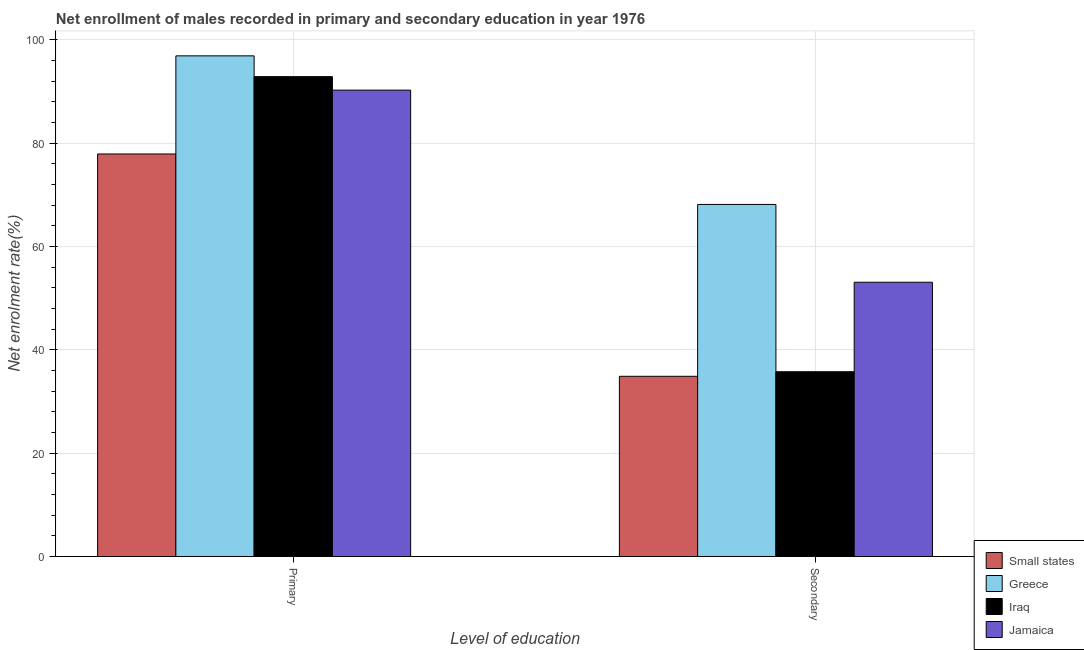How many different coloured bars are there?
Give a very brief answer. 4. Are the number of bars on each tick of the X-axis equal?
Ensure brevity in your answer.  Yes. How many bars are there on the 2nd tick from the left?
Your response must be concise. 4. What is the label of the 2nd group of bars from the left?
Offer a terse response. Secondary. What is the enrollment rate in secondary education in Iraq?
Make the answer very short. 35.76. Across all countries, what is the maximum enrollment rate in primary education?
Your answer should be very brief. 96.88. Across all countries, what is the minimum enrollment rate in primary education?
Ensure brevity in your answer.  77.89. In which country was the enrollment rate in primary education minimum?
Give a very brief answer. Small states. What is the total enrollment rate in primary education in the graph?
Provide a short and direct response. 357.87. What is the difference between the enrollment rate in primary education in Small states and that in Greece?
Keep it short and to the point. -18.99. What is the difference between the enrollment rate in secondary education in Iraq and the enrollment rate in primary education in Jamaica?
Offer a very short reply. -54.49. What is the average enrollment rate in secondary education per country?
Offer a terse response. 47.96. What is the difference between the enrollment rate in secondary education and enrollment rate in primary education in Iraq?
Provide a succinct answer. -57.1. In how many countries, is the enrollment rate in secondary education greater than 52 %?
Your answer should be compact. 2. What is the ratio of the enrollment rate in secondary education in Greece to that in Iraq?
Offer a very short reply. 1.91. In how many countries, is the enrollment rate in primary education greater than the average enrollment rate in primary education taken over all countries?
Keep it short and to the point. 3. What does the 1st bar from the left in Primary represents?
Make the answer very short. Small states. What does the 1st bar from the right in Primary represents?
Your answer should be very brief. Jamaica. How many bars are there?
Provide a short and direct response. 8. How many countries are there in the graph?
Offer a terse response. 4. What is the difference between two consecutive major ticks on the Y-axis?
Keep it short and to the point. 20. Does the graph contain grids?
Offer a terse response. Yes. Where does the legend appear in the graph?
Keep it short and to the point. Bottom right. How many legend labels are there?
Offer a very short reply. 4. How are the legend labels stacked?
Make the answer very short. Vertical. What is the title of the graph?
Provide a short and direct response. Net enrollment of males recorded in primary and secondary education in year 1976. What is the label or title of the X-axis?
Keep it short and to the point. Level of education. What is the label or title of the Y-axis?
Make the answer very short. Net enrolment rate(%). What is the Net enrolment rate(%) in Small states in Primary?
Your answer should be very brief. 77.89. What is the Net enrolment rate(%) of Greece in Primary?
Keep it short and to the point. 96.88. What is the Net enrolment rate(%) in Iraq in Primary?
Offer a very short reply. 92.85. What is the Net enrolment rate(%) in Jamaica in Primary?
Offer a terse response. 90.25. What is the Net enrolment rate(%) of Small states in Secondary?
Your response must be concise. 34.87. What is the Net enrolment rate(%) of Greece in Secondary?
Ensure brevity in your answer.  68.12. What is the Net enrolment rate(%) of Iraq in Secondary?
Your answer should be compact. 35.76. What is the Net enrolment rate(%) in Jamaica in Secondary?
Make the answer very short. 53.07. Across all Level of education, what is the maximum Net enrolment rate(%) of Small states?
Offer a terse response. 77.89. Across all Level of education, what is the maximum Net enrolment rate(%) in Greece?
Ensure brevity in your answer.  96.88. Across all Level of education, what is the maximum Net enrolment rate(%) of Iraq?
Your answer should be compact. 92.85. Across all Level of education, what is the maximum Net enrolment rate(%) of Jamaica?
Make the answer very short. 90.25. Across all Level of education, what is the minimum Net enrolment rate(%) of Small states?
Give a very brief answer. 34.87. Across all Level of education, what is the minimum Net enrolment rate(%) of Greece?
Provide a succinct answer. 68.12. Across all Level of education, what is the minimum Net enrolment rate(%) in Iraq?
Ensure brevity in your answer.  35.76. Across all Level of education, what is the minimum Net enrolment rate(%) of Jamaica?
Make the answer very short. 53.07. What is the total Net enrolment rate(%) of Small states in the graph?
Your answer should be very brief. 112.76. What is the total Net enrolment rate(%) of Greece in the graph?
Make the answer very short. 165. What is the total Net enrolment rate(%) in Iraq in the graph?
Your answer should be very brief. 128.61. What is the total Net enrolment rate(%) of Jamaica in the graph?
Your answer should be very brief. 143.32. What is the difference between the Net enrolment rate(%) in Small states in Primary and that in Secondary?
Your answer should be compact. 43.02. What is the difference between the Net enrolment rate(%) of Greece in Primary and that in Secondary?
Make the answer very short. 28.75. What is the difference between the Net enrolment rate(%) in Iraq in Primary and that in Secondary?
Give a very brief answer. 57.1. What is the difference between the Net enrolment rate(%) of Jamaica in Primary and that in Secondary?
Offer a very short reply. 37.17. What is the difference between the Net enrolment rate(%) of Small states in Primary and the Net enrolment rate(%) of Greece in Secondary?
Offer a terse response. 9.77. What is the difference between the Net enrolment rate(%) in Small states in Primary and the Net enrolment rate(%) in Iraq in Secondary?
Your answer should be compact. 42.13. What is the difference between the Net enrolment rate(%) in Small states in Primary and the Net enrolment rate(%) in Jamaica in Secondary?
Your response must be concise. 24.82. What is the difference between the Net enrolment rate(%) of Greece in Primary and the Net enrolment rate(%) of Iraq in Secondary?
Ensure brevity in your answer.  61.12. What is the difference between the Net enrolment rate(%) in Greece in Primary and the Net enrolment rate(%) in Jamaica in Secondary?
Offer a terse response. 43.81. What is the difference between the Net enrolment rate(%) in Iraq in Primary and the Net enrolment rate(%) in Jamaica in Secondary?
Your answer should be compact. 39.78. What is the average Net enrolment rate(%) of Small states per Level of education?
Your response must be concise. 56.38. What is the average Net enrolment rate(%) in Greece per Level of education?
Provide a succinct answer. 82.5. What is the average Net enrolment rate(%) of Iraq per Level of education?
Keep it short and to the point. 64.31. What is the average Net enrolment rate(%) of Jamaica per Level of education?
Offer a terse response. 71.66. What is the difference between the Net enrolment rate(%) of Small states and Net enrolment rate(%) of Greece in Primary?
Your answer should be very brief. -18.99. What is the difference between the Net enrolment rate(%) in Small states and Net enrolment rate(%) in Iraq in Primary?
Your answer should be compact. -14.96. What is the difference between the Net enrolment rate(%) of Small states and Net enrolment rate(%) of Jamaica in Primary?
Give a very brief answer. -12.36. What is the difference between the Net enrolment rate(%) in Greece and Net enrolment rate(%) in Iraq in Primary?
Ensure brevity in your answer.  4.02. What is the difference between the Net enrolment rate(%) of Greece and Net enrolment rate(%) of Jamaica in Primary?
Your response must be concise. 6.63. What is the difference between the Net enrolment rate(%) in Iraq and Net enrolment rate(%) in Jamaica in Primary?
Your answer should be compact. 2.61. What is the difference between the Net enrolment rate(%) of Small states and Net enrolment rate(%) of Greece in Secondary?
Provide a short and direct response. -33.25. What is the difference between the Net enrolment rate(%) of Small states and Net enrolment rate(%) of Iraq in Secondary?
Your answer should be compact. -0.89. What is the difference between the Net enrolment rate(%) in Small states and Net enrolment rate(%) in Jamaica in Secondary?
Provide a short and direct response. -18.2. What is the difference between the Net enrolment rate(%) of Greece and Net enrolment rate(%) of Iraq in Secondary?
Your answer should be very brief. 32.37. What is the difference between the Net enrolment rate(%) in Greece and Net enrolment rate(%) in Jamaica in Secondary?
Your answer should be compact. 15.05. What is the difference between the Net enrolment rate(%) of Iraq and Net enrolment rate(%) of Jamaica in Secondary?
Ensure brevity in your answer.  -17.32. What is the ratio of the Net enrolment rate(%) in Small states in Primary to that in Secondary?
Make the answer very short. 2.23. What is the ratio of the Net enrolment rate(%) of Greece in Primary to that in Secondary?
Keep it short and to the point. 1.42. What is the ratio of the Net enrolment rate(%) of Iraq in Primary to that in Secondary?
Provide a short and direct response. 2.6. What is the ratio of the Net enrolment rate(%) in Jamaica in Primary to that in Secondary?
Keep it short and to the point. 1.7. What is the difference between the highest and the second highest Net enrolment rate(%) in Small states?
Give a very brief answer. 43.02. What is the difference between the highest and the second highest Net enrolment rate(%) in Greece?
Your answer should be compact. 28.75. What is the difference between the highest and the second highest Net enrolment rate(%) of Iraq?
Ensure brevity in your answer.  57.1. What is the difference between the highest and the second highest Net enrolment rate(%) of Jamaica?
Your answer should be very brief. 37.17. What is the difference between the highest and the lowest Net enrolment rate(%) in Small states?
Make the answer very short. 43.02. What is the difference between the highest and the lowest Net enrolment rate(%) of Greece?
Give a very brief answer. 28.75. What is the difference between the highest and the lowest Net enrolment rate(%) of Iraq?
Provide a short and direct response. 57.1. What is the difference between the highest and the lowest Net enrolment rate(%) in Jamaica?
Provide a succinct answer. 37.17. 